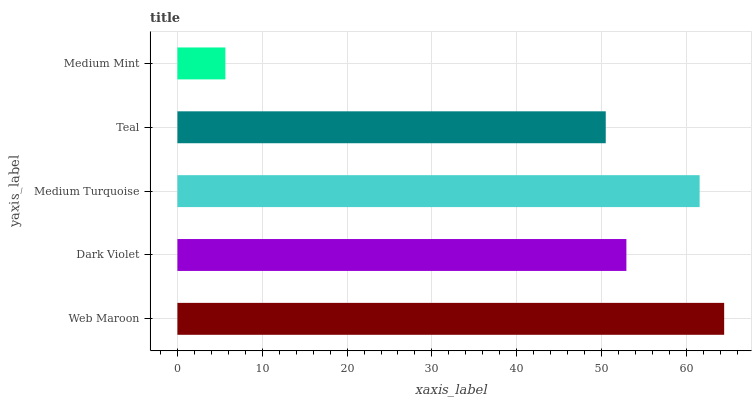Is Medium Mint the minimum?
Answer yes or no. Yes. Is Web Maroon the maximum?
Answer yes or no. Yes. Is Dark Violet the minimum?
Answer yes or no. No. Is Dark Violet the maximum?
Answer yes or no. No. Is Web Maroon greater than Dark Violet?
Answer yes or no. Yes. Is Dark Violet less than Web Maroon?
Answer yes or no. Yes. Is Dark Violet greater than Web Maroon?
Answer yes or no. No. Is Web Maroon less than Dark Violet?
Answer yes or no. No. Is Dark Violet the high median?
Answer yes or no. Yes. Is Dark Violet the low median?
Answer yes or no. Yes. Is Teal the high median?
Answer yes or no. No. Is Teal the low median?
Answer yes or no. No. 